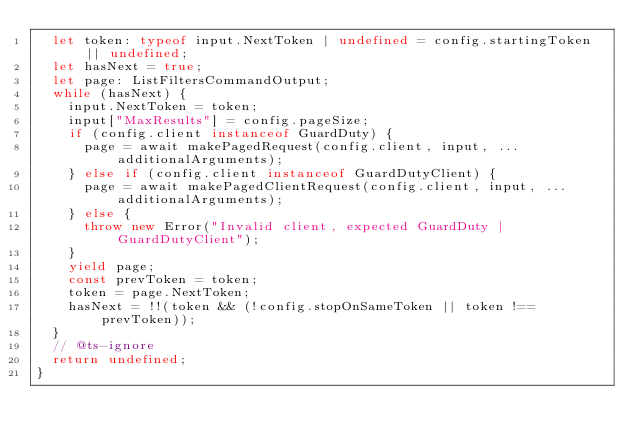<code> <loc_0><loc_0><loc_500><loc_500><_TypeScript_>  let token: typeof input.NextToken | undefined = config.startingToken || undefined;
  let hasNext = true;
  let page: ListFiltersCommandOutput;
  while (hasNext) {
    input.NextToken = token;
    input["MaxResults"] = config.pageSize;
    if (config.client instanceof GuardDuty) {
      page = await makePagedRequest(config.client, input, ...additionalArguments);
    } else if (config.client instanceof GuardDutyClient) {
      page = await makePagedClientRequest(config.client, input, ...additionalArguments);
    } else {
      throw new Error("Invalid client, expected GuardDuty | GuardDutyClient");
    }
    yield page;
    const prevToken = token;
    token = page.NextToken;
    hasNext = !!(token && (!config.stopOnSameToken || token !== prevToken));
  }
  // @ts-ignore
  return undefined;
}
</code> 